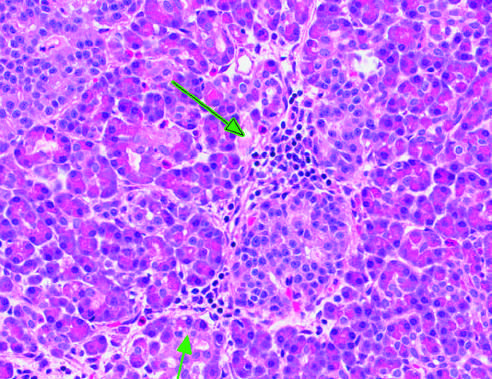what point to inflammation surrounding islet of langerhans?
Answer the question using a single word or phrase. Arrows 